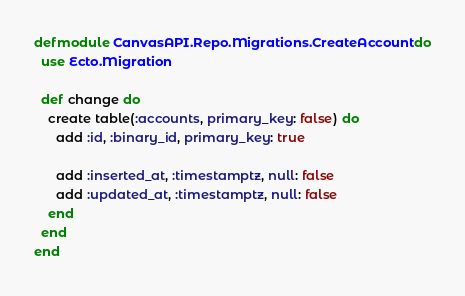<code> <loc_0><loc_0><loc_500><loc_500><_Elixir_>defmodule CanvasAPI.Repo.Migrations.CreateAccount do
  use Ecto.Migration

  def change do
    create table(:accounts, primary_key: false) do
      add :id, :binary_id, primary_key: true

      add :inserted_at, :timestamptz, null: false
      add :updated_at, :timestamptz, null: false
    end
  end
end
</code> 